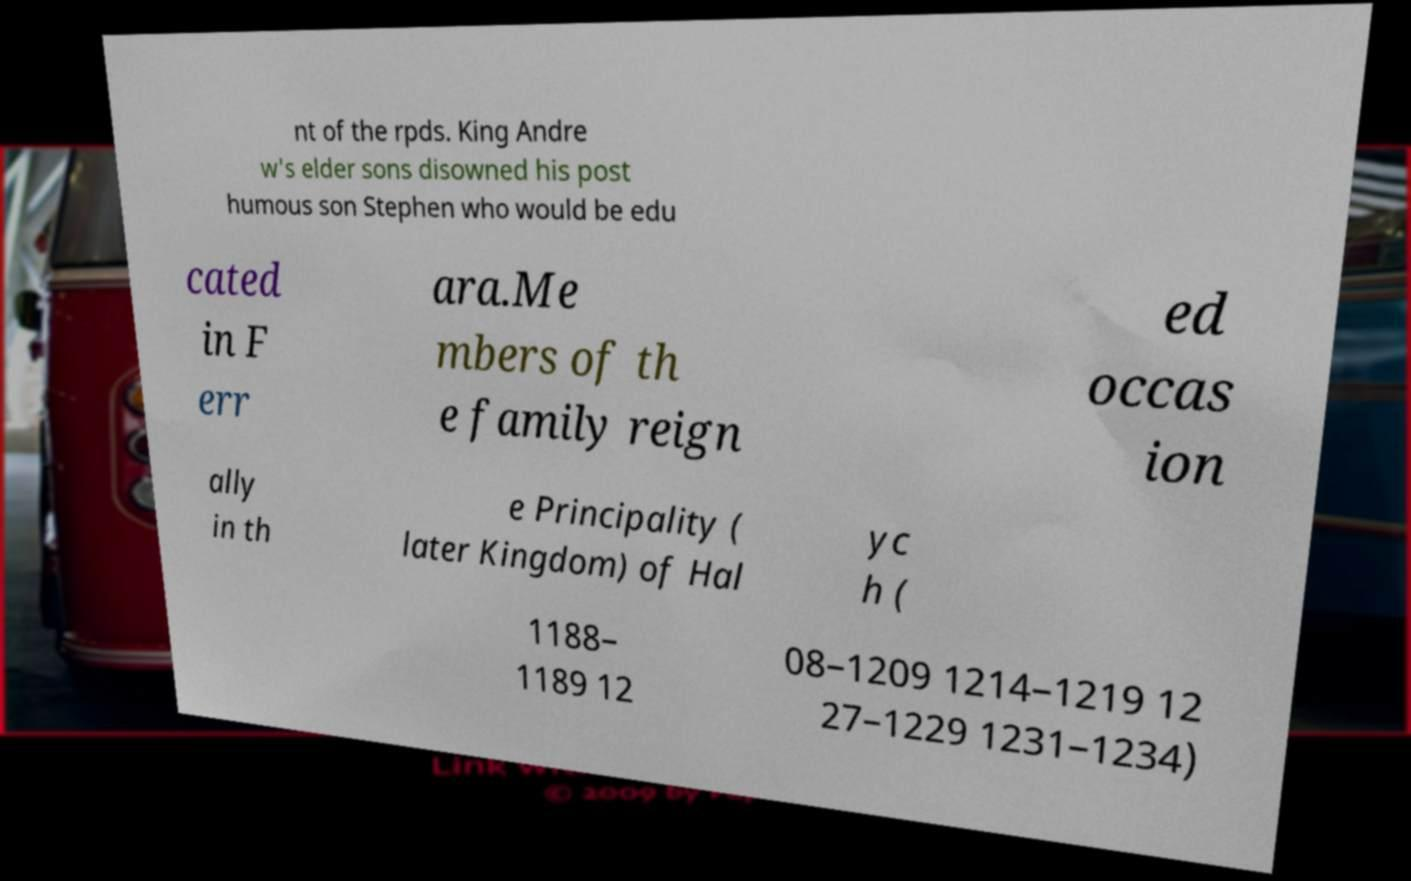Please identify and transcribe the text found in this image. nt of the rpds. King Andre w's elder sons disowned his post humous son Stephen who would be edu cated in F err ara.Me mbers of th e family reign ed occas ion ally in th e Principality ( later Kingdom) of Hal yc h ( 1188– 1189 12 08–1209 1214–1219 12 27–1229 1231–1234) 